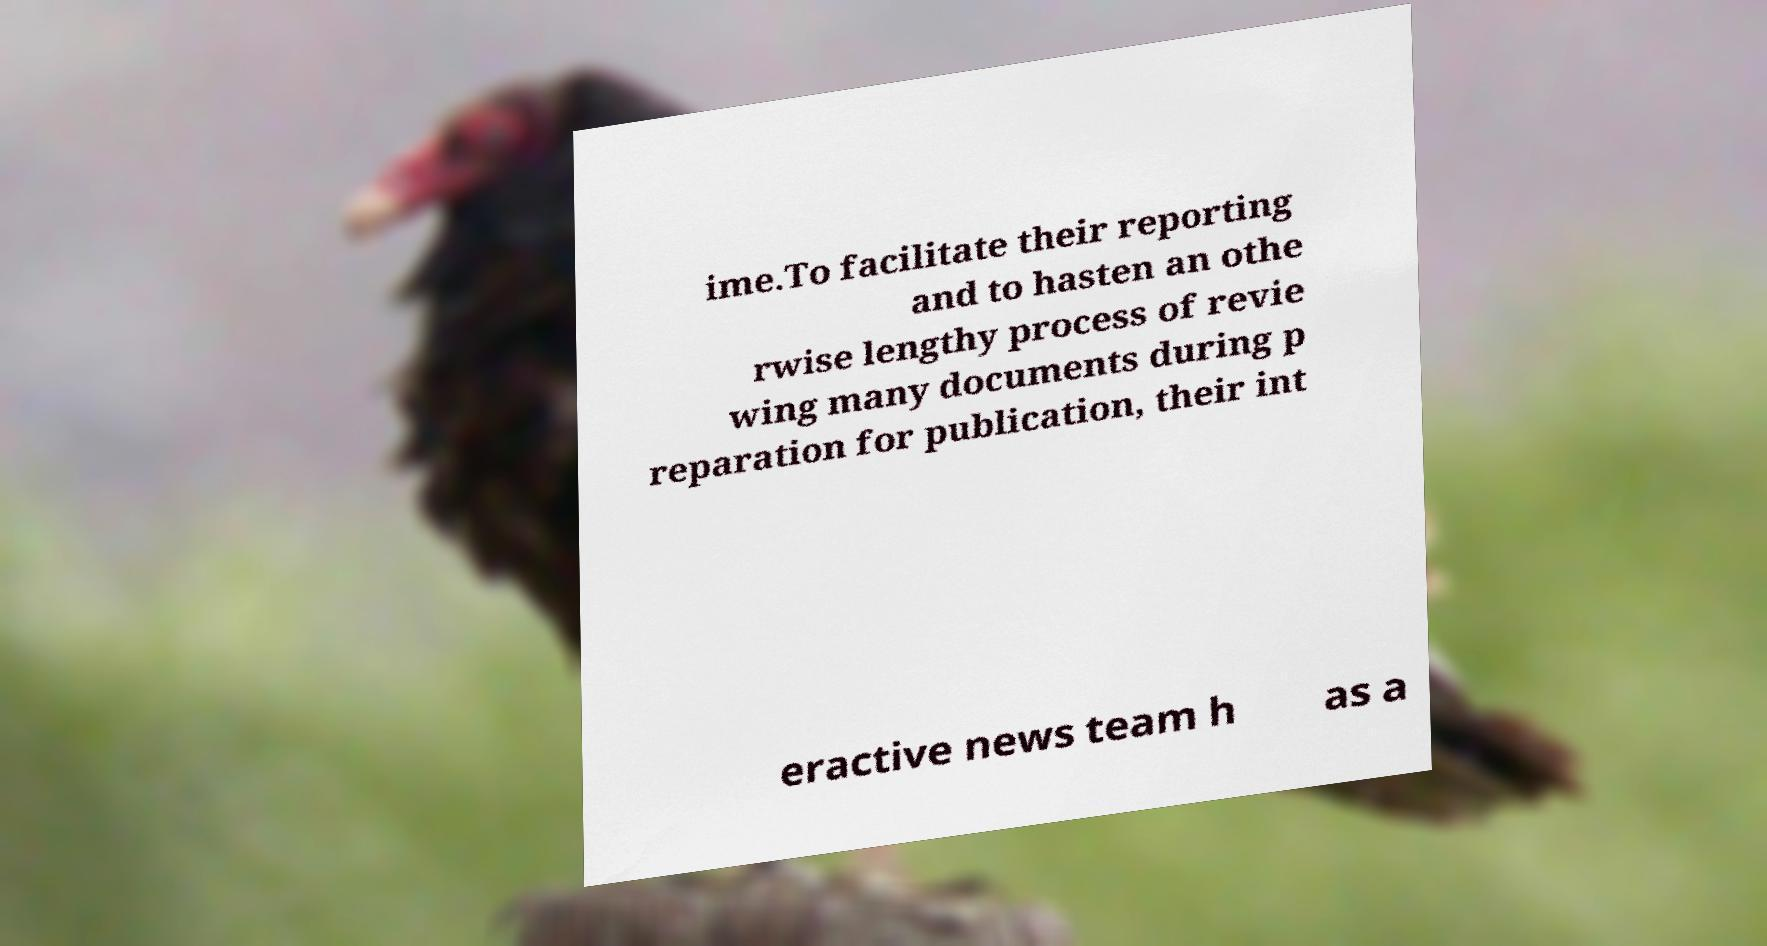There's text embedded in this image that I need extracted. Can you transcribe it verbatim? ime.To facilitate their reporting and to hasten an othe rwise lengthy process of revie wing many documents during p reparation for publication, their int eractive news team h as a 